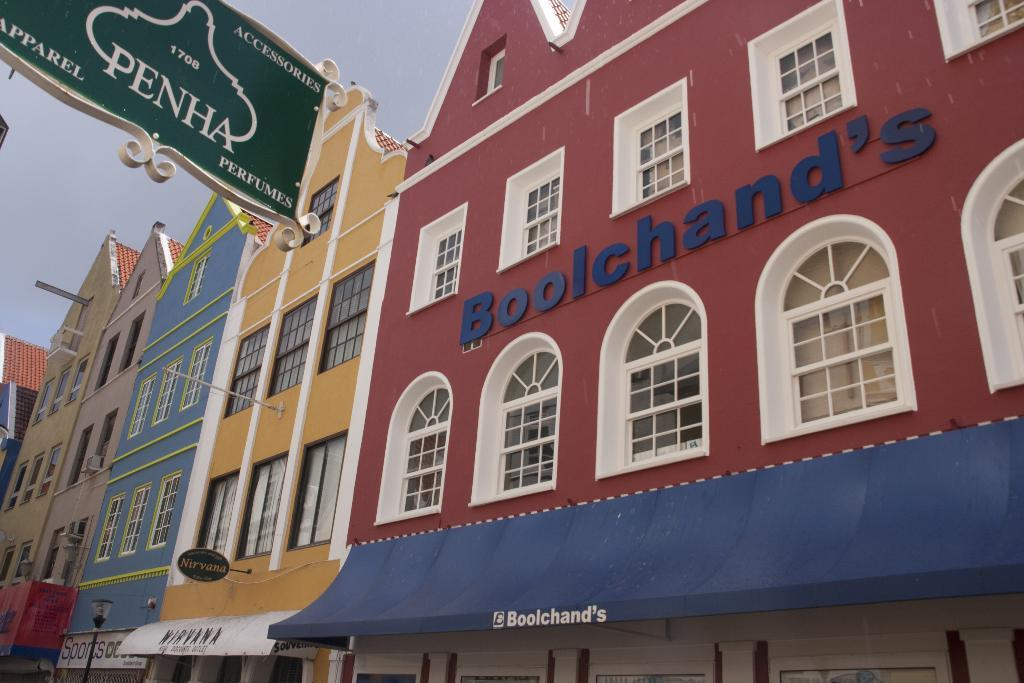What type of structure is visible in the image? There is a building in the image. What feature can be observed on the building? The building has glass windows. What is located on the top left side of the image? There is a hoarding board on the top left side of the image. What can be seen on the bottom left side of the image? There is a decorative light pole on the bottom left side of the image. What type of lumber is being used to construct the building in the image? There is no visible lumber being used in the construction of the building in the image. 